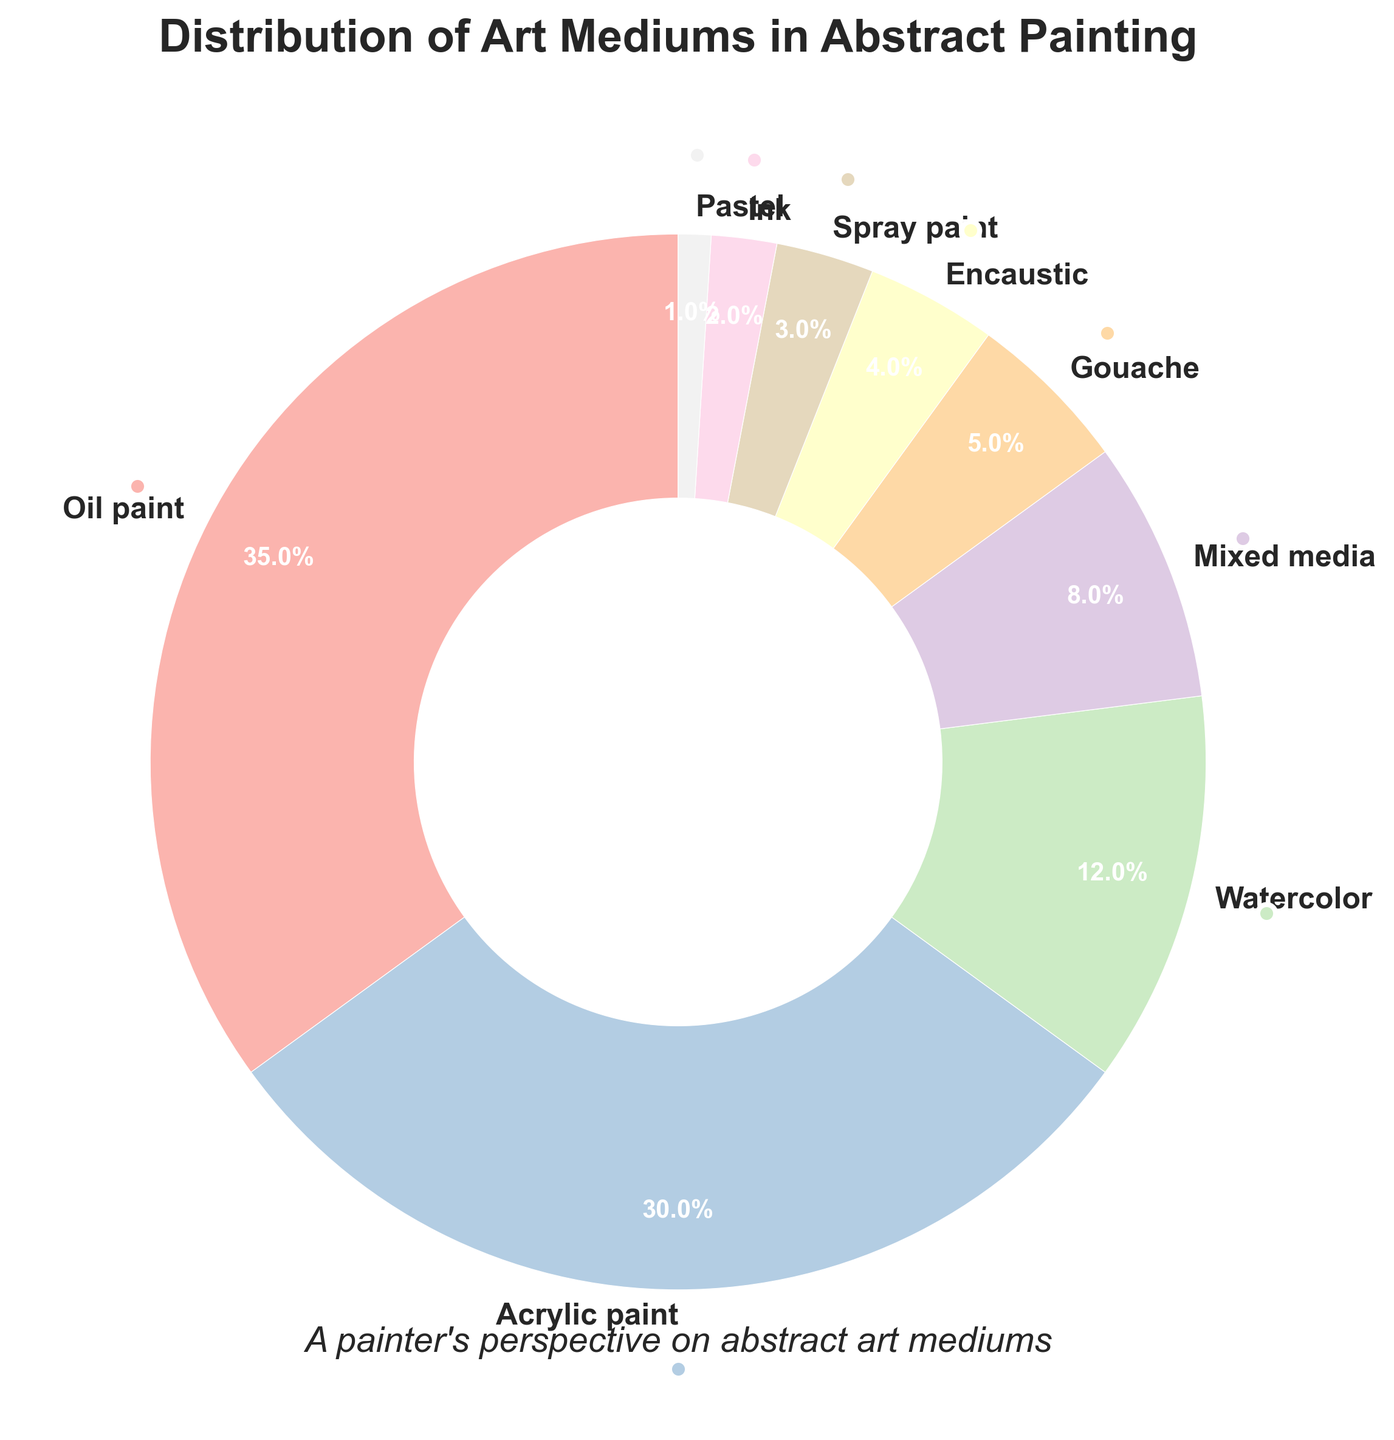What is the sum of the percentages for Oil paint and Acrylic paint? To find the sum, add the percentage for Oil paint (35%) to the percentage for Acrylic paint (30%). That gives 35 + 30 = 65.
Answer: 65% Which medium has the lowest percentage? By looking at the smallest slice in the pie chart, we can see that Pastel has the smallest percentage at 1%.
Answer: Pastel How does the percentage of Watercolor compare to that of Gouache? Watercolor has a percentage of 12%, while Gouache has 5%. Watercolor has a higher percentage than Gouache.
Answer: Watercolor What is the combined percentage of Watercolor and Mixed media? Add the percentage of Watercolor (12%) to that of Mixed media (8%). That gives 12 + 8 = 20.
Answer: 20% If you combine the percentages of Oil paint, Acrylic paint, and Watercolor, how much of the total does this group represent? Add the percentages of Oil paint (35%), Acrylic paint (30%), and Watercolor (12%). That gives 35 + 30 + 12 = 77.
Answer: 77% Which medium has a larger proportion, Spray paint or Ink? Spray paint has a percentage of 3%, while Ink has 2%. Spray paint has a larger proportion than Ink.
Answer: Spray paint Which mediums together make up less than 10% of the total? Combined percentages of Encaustic (4%), Spray paint (3%), Ink (2%), and Pastel (1%) add up to 4 + 3 + 2 + 1 = 10. So all these mediums together make up less than 10%.
Answer: Encaustic, Spray paint, Ink, Pastel What percentage of mediums used are equal to or greater than 5% each? Oil paint (35%), Acrylic paint (30%), Watercolor (12%), and Mixed media (8%) are all individually greater than 5%. Gouache (5%) is equal to 5%. Summing these: 35 + 30 + 12 + 8 + 5 = 90.
Answer: 90% Which slices in the pie chart appear the largest and smallest in terms of visual size? The largest slice corresponds to Oil paint (35%), and the smallest slice corresponds to Pastel (1%).
Answer: Oil paint, Pastel 